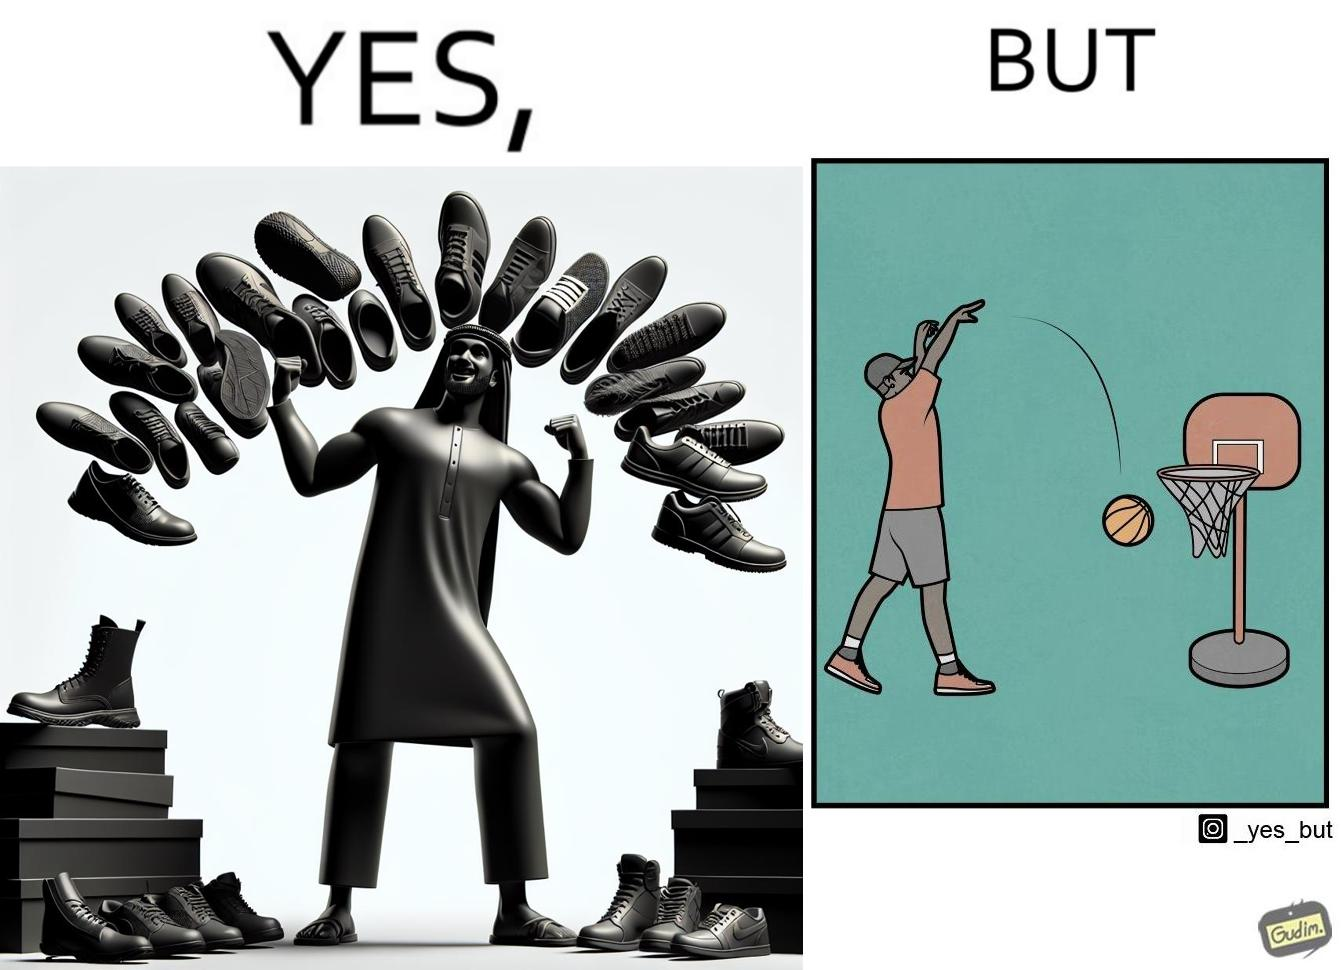Describe what you see in this image. The image is ironic, because even when the person has a large collection of shoes even then he is not able to basket a ball in a small height net 